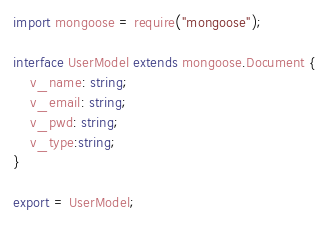Convert code to text. <code><loc_0><loc_0><loc_500><loc_500><_TypeScript_>import mongoose = require("mongoose");

interface UserModel extends mongoose.Document {
    v_name: string;
    v_email: string;
    v_pwd: string;
    v_type:string;
}

export = UserModel;</code> 